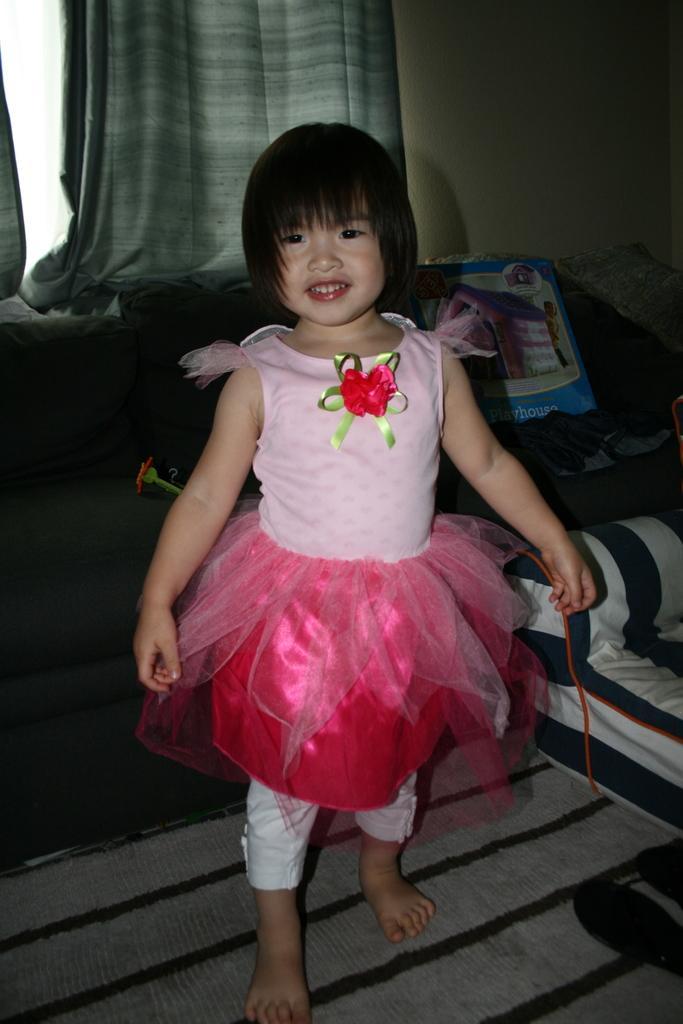In one or two sentences, can you explain what this image depicts? In this image I can see a girl is standing and smiling. In the background I can see curtains, a wall and other objects on the floor. 